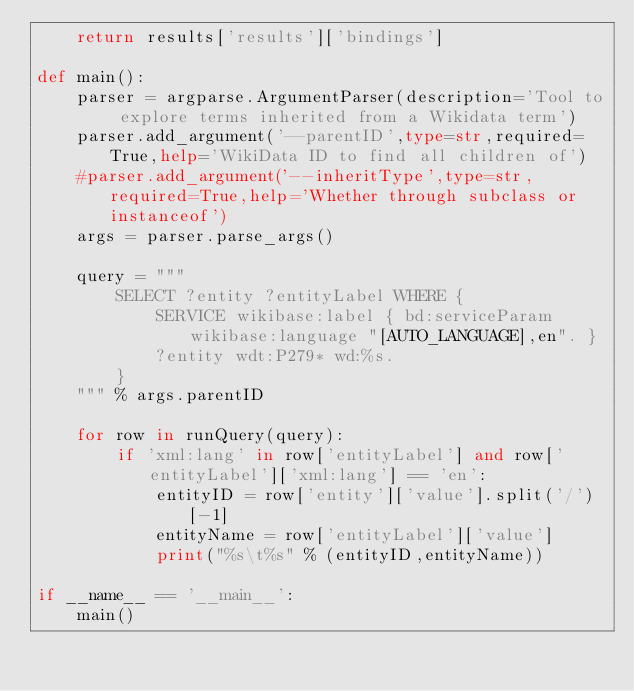<code> <loc_0><loc_0><loc_500><loc_500><_Python_>	return results['results']['bindings']
	
def main():
	parser = argparse.ArgumentParser(description='Tool to explore terms inherited from a Wikidata term')
	parser.add_argument('--parentID',type=str,required=True,help='WikiData ID to find all children of')
	#parser.add_argument('--inheritType',type=str,required=True,help='Whether through subclass or instanceof')
	args = parser.parse_args()
	
	query = """
		SELECT ?entity ?entityLabel WHERE {
			SERVICE wikibase:label { bd:serviceParam wikibase:language "[AUTO_LANGUAGE],en". }
			?entity wdt:P279* wd:%s.
		} 
	""" % args.parentID
	
	for row in runQuery(query):
		if 'xml:lang' in row['entityLabel'] and row['entityLabel']['xml:lang'] == 'en':
			entityID = row['entity']['value'].split('/')[-1]
			entityName = row['entityLabel']['value']
			print("%s\t%s" % (entityID,entityName))
			
if __name__ == '__main__':
	main()

</code> 